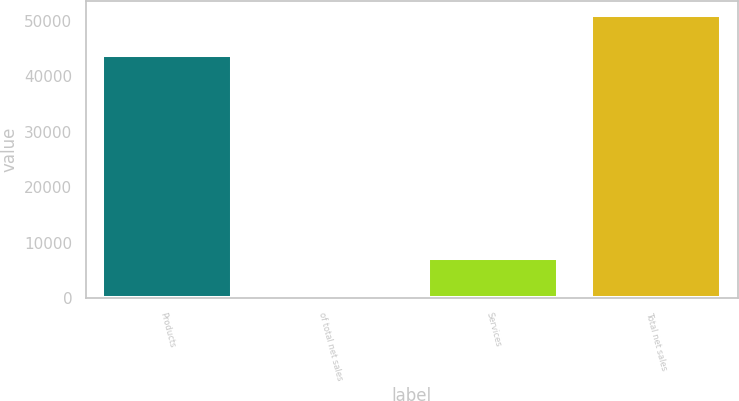Convert chart. <chart><loc_0><loc_0><loc_500><loc_500><bar_chart><fcel>Products<fcel>of total net sales<fcel>Services<fcel>Total net sales<nl><fcel>43875<fcel>85.9<fcel>7173<fcel>51048<nl></chart> 